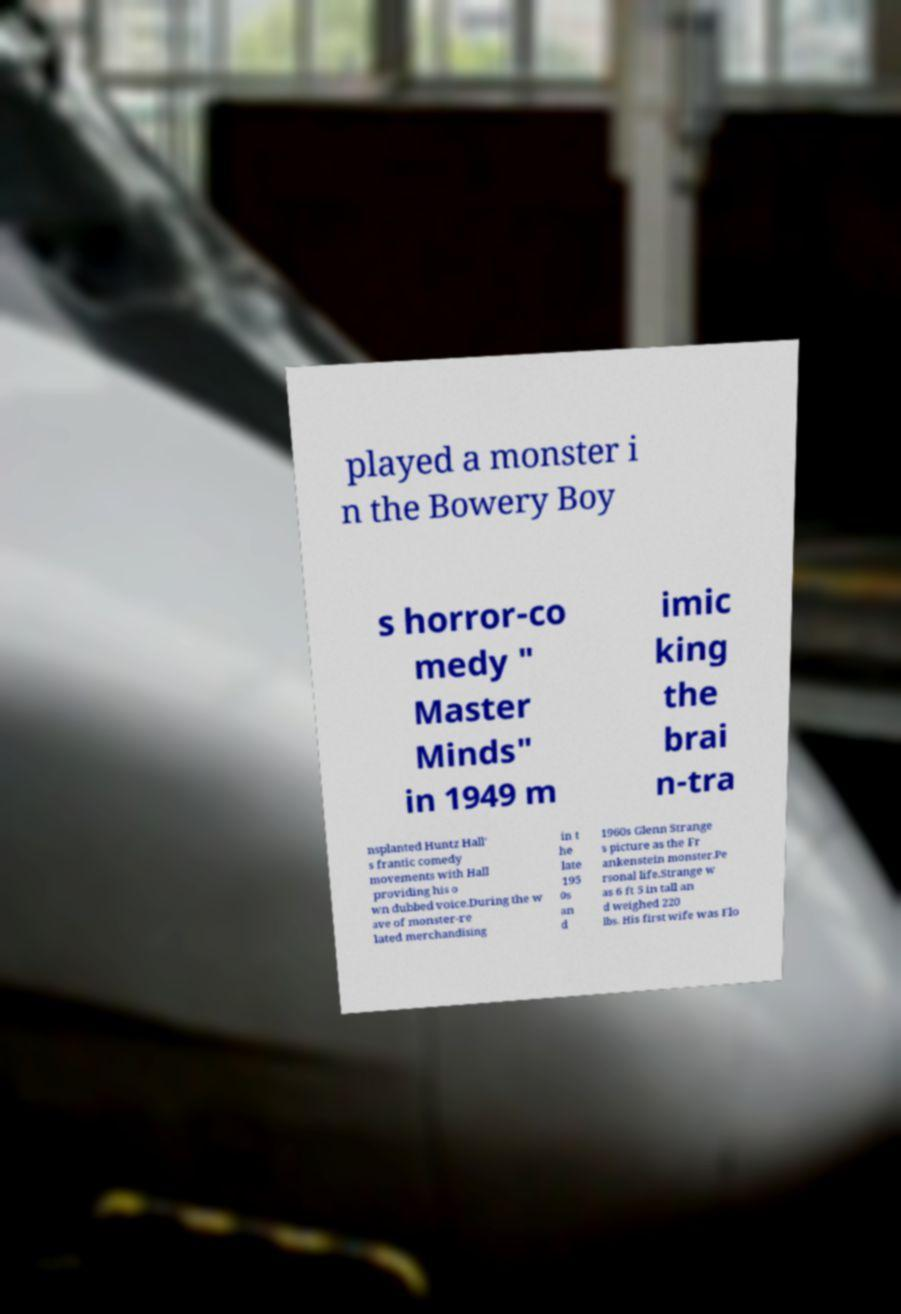Can you read and provide the text displayed in the image?This photo seems to have some interesting text. Can you extract and type it out for me? played a monster i n the Bowery Boy s horror-co medy " Master Minds" in 1949 m imic king the brai n-tra nsplanted Huntz Hall' s frantic comedy movements with Hall providing his o wn dubbed voice.During the w ave of monster-re lated merchandising in t he late 195 0s an d 1960s Glenn Strange s picture as the Fr ankenstein monster.Pe rsonal life.Strange w as 6 ft 5 in tall an d weighed 220 lbs. His first wife was Flo 